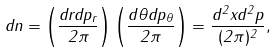Convert formula to latex. <formula><loc_0><loc_0><loc_500><loc_500>d n = \left ( \frac { d r d p _ { r } } { 2 \pi } \right ) \left ( \frac { d \theta d p _ { \theta } } { 2 \pi } \right ) = \frac { d ^ { 2 } x d ^ { 2 } p } { ( 2 \pi ) ^ { 2 } } ,</formula> 